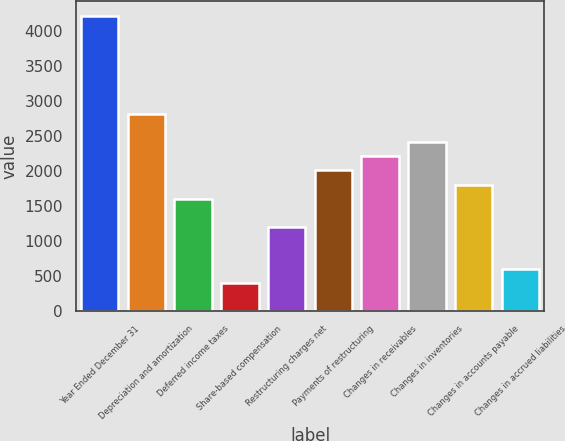<chart> <loc_0><loc_0><loc_500><loc_500><bar_chart><fcel>Year Ended December 31<fcel>Depreciation and amortization<fcel>Deferred income taxes<fcel>Share-based compensation<fcel>Restructuring charges net<fcel>Payments of restructuring<fcel>Changes in receivables<fcel>Changes in inventories<fcel>Changes in accounts payable<fcel>Changes in accrued liabilities<nl><fcel>4217.8<fcel>2812.2<fcel>1607.4<fcel>402.6<fcel>1205.8<fcel>2009<fcel>2209.8<fcel>2410.6<fcel>1808.2<fcel>603.4<nl></chart> 